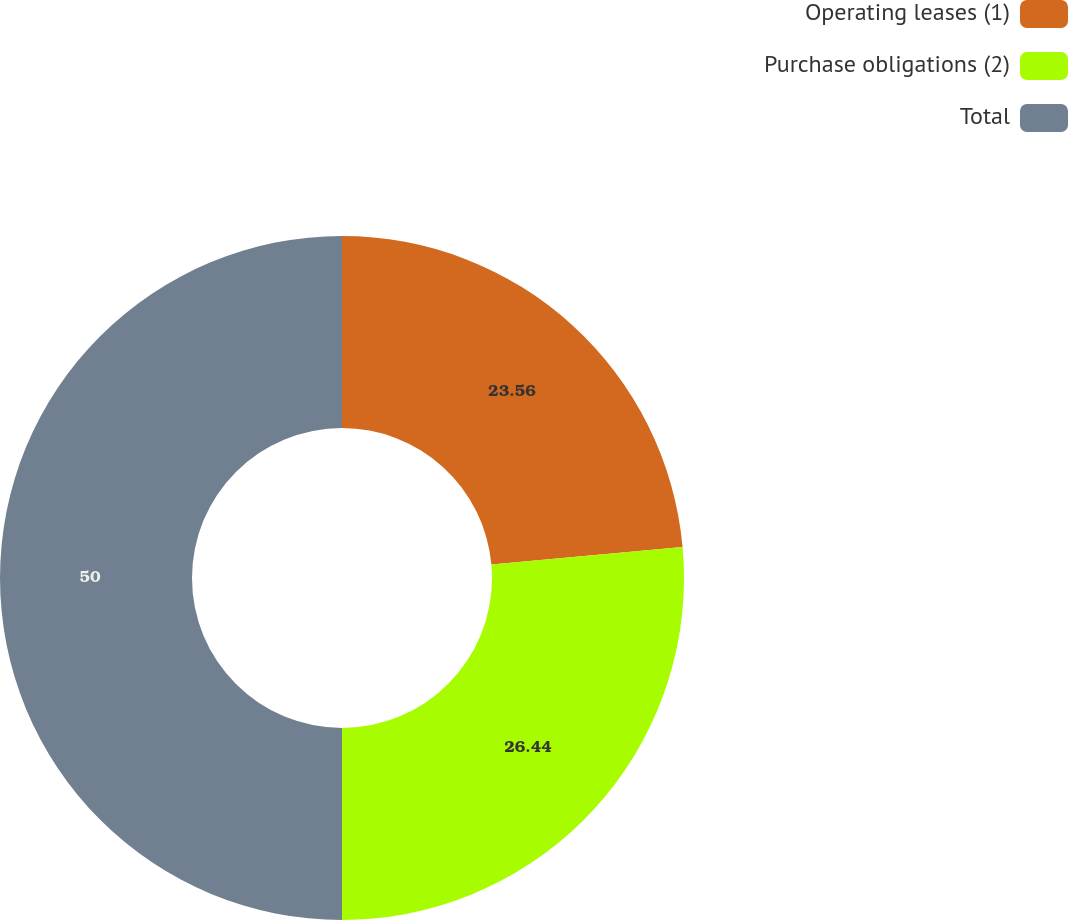Convert chart. <chart><loc_0><loc_0><loc_500><loc_500><pie_chart><fcel>Operating leases (1)<fcel>Purchase obligations (2)<fcel>Total<nl><fcel>23.56%<fcel>26.44%<fcel>50.0%<nl></chart> 